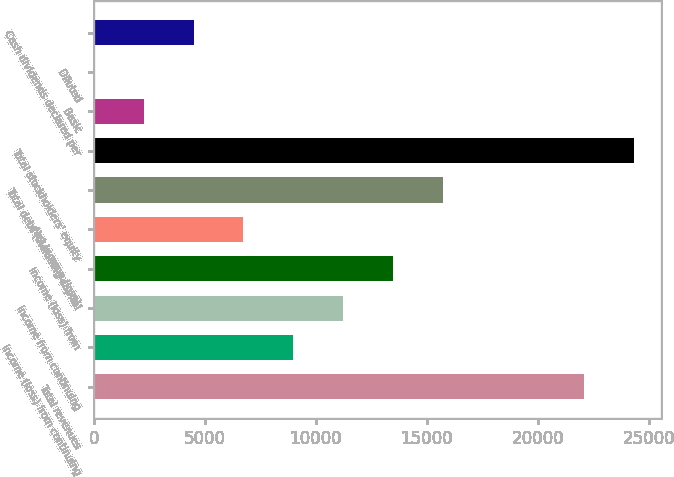<chart> <loc_0><loc_0><loc_500><loc_500><bar_chart><fcel>Total revenues<fcel>Income (loss) from continuing<fcel>Income from continuing<fcel>Income (loss) from<fcel>Net income (loss)<fcel>Total debt (including capital<fcel>Total stockholders' equity<fcel>Basic<fcel>Diluted<fcel>Cash dividends declared per<nl><fcel>22086<fcel>8978.89<fcel>11223.6<fcel>13468.2<fcel>6734.21<fcel>15712.9<fcel>24330.7<fcel>2244.85<fcel>0.17<fcel>4489.53<nl></chart> 